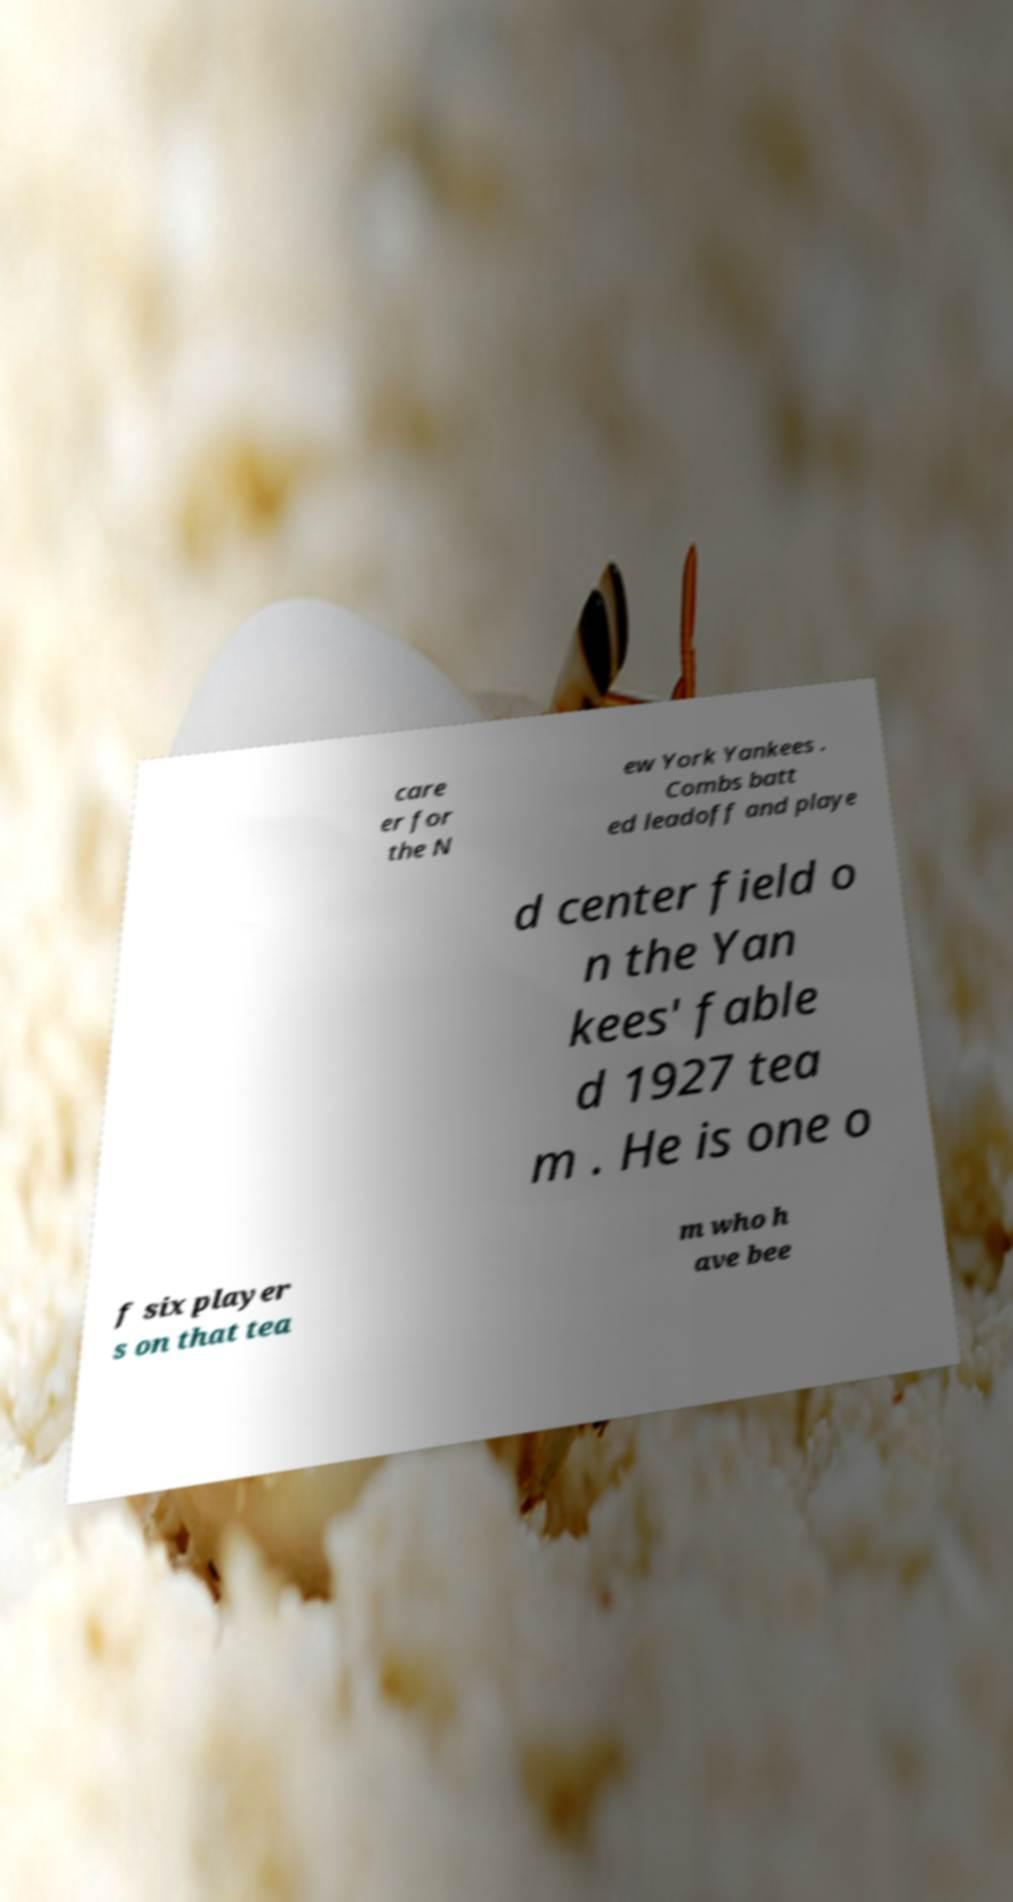What messages or text are displayed in this image? I need them in a readable, typed format. care er for the N ew York Yankees . Combs batt ed leadoff and playe d center field o n the Yan kees' fable d 1927 tea m . He is one o f six player s on that tea m who h ave bee 